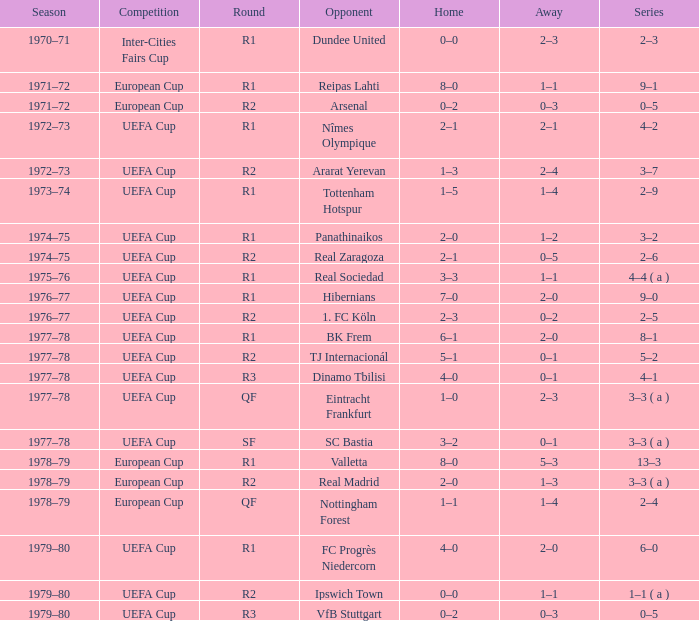Could you help me parse every detail presented in this table? {'header': ['Season', 'Competition', 'Round', 'Opponent', 'Home', 'Away', 'Series'], 'rows': [['1970–71', 'Inter-Cities Fairs Cup', 'R1', 'Dundee United', '0–0', '2–3', '2–3'], ['1971–72', 'European Cup', 'R1', 'Reipas Lahti', '8–0', '1–1', '9–1'], ['1971–72', 'European Cup', 'R2', 'Arsenal', '0–2', '0–3', '0–5'], ['1972–73', 'UEFA Cup', 'R1', 'Nîmes Olympique', '2–1', '2–1', '4–2'], ['1972–73', 'UEFA Cup', 'R2', 'Ararat Yerevan', '1–3', '2–4', '3–7'], ['1973–74', 'UEFA Cup', 'R1', 'Tottenham Hotspur', '1–5', '1–4', '2–9'], ['1974–75', 'UEFA Cup', 'R1', 'Panathinaikos', '2–0', '1–2', '3–2'], ['1974–75', 'UEFA Cup', 'R2', 'Real Zaragoza', '2–1', '0–5', '2–6'], ['1975–76', 'UEFA Cup', 'R1', 'Real Sociedad', '3–3', '1–1', '4–4 ( a )'], ['1976–77', 'UEFA Cup', 'R1', 'Hibernians', '7–0', '2–0', '9–0'], ['1976–77', 'UEFA Cup', 'R2', '1. FC Köln', '2–3', '0–2', '2–5'], ['1977–78', 'UEFA Cup', 'R1', 'BK Frem', '6–1', '2–0', '8–1'], ['1977–78', 'UEFA Cup', 'R2', 'TJ Internacionál', '5–1', '0–1', '5–2'], ['1977–78', 'UEFA Cup', 'R3', 'Dinamo Tbilisi', '4–0', '0–1', '4–1'], ['1977–78', 'UEFA Cup', 'QF', 'Eintracht Frankfurt', '1–0', '2–3', '3–3 ( a )'], ['1977–78', 'UEFA Cup', 'SF', 'SC Bastia', '3–2', '0–1', '3–3 ( a )'], ['1978–79', 'European Cup', 'R1', 'Valletta', '8–0', '5–3', '13–3'], ['1978–79', 'European Cup', 'R2', 'Real Madrid', '2–0', '1–3', '3–3 ( a )'], ['1978–79', 'European Cup', 'QF', 'Nottingham Forest', '1–1', '1–4', '2–4'], ['1979–80', 'UEFA Cup', 'R1', 'FC Progrès Niedercorn', '4–0', '2–0', '6–0'], ['1979–80', 'UEFA Cup', 'R2', 'Ipswich Town', '0–0', '1–1', '1–1 ( a )'], ['1979–80', 'UEFA Cup', 'R3', 'VfB Stuttgart', '0–2', '0–3', '0–5']]} Which Season has an Opponent of hibernians? 1976–77. 